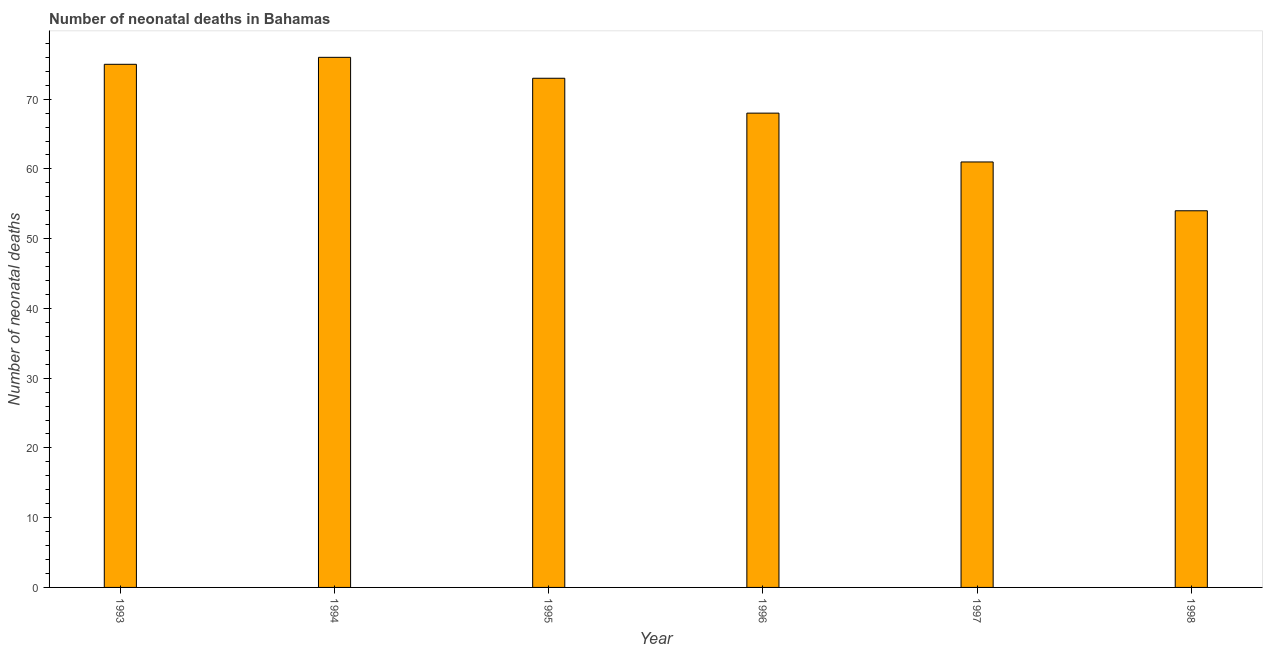Does the graph contain any zero values?
Provide a short and direct response. No. Does the graph contain grids?
Provide a short and direct response. No. What is the title of the graph?
Offer a very short reply. Number of neonatal deaths in Bahamas. What is the label or title of the Y-axis?
Provide a short and direct response. Number of neonatal deaths. What is the number of neonatal deaths in 1997?
Provide a short and direct response. 61. Across all years, what is the minimum number of neonatal deaths?
Make the answer very short. 54. What is the sum of the number of neonatal deaths?
Give a very brief answer. 407. What is the difference between the number of neonatal deaths in 1993 and 1998?
Give a very brief answer. 21. What is the average number of neonatal deaths per year?
Offer a terse response. 67. What is the median number of neonatal deaths?
Ensure brevity in your answer.  70.5. In how many years, is the number of neonatal deaths greater than 40 ?
Make the answer very short. 6. What is the ratio of the number of neonatal deaths in 1993 to that in 1998?
Ensure brevity in your answer.  1.39. Is the number of neonatal deaths in 1993 less than that in 1994?
Make the answer very short. Yes. Is the difference between the number of neonatal deaths in 1993 and 1998 greater than the difference between any two years?
Your answer should be compact. No. What is the difference between the highest and the second highest number of neonatal deaths?
Keep it short and to the point. 1. In how many years, is the number of neonatal deaths greater than the average number of neonatal deaths taken over all years?
Keep it short and to the point. 4. What is the difference between two consecutive major ticks on the Y-axis?
Give a very brief answer. 10. Are the values on the major ticks of Y-axis written in scientific E-notation?
Your response must be concise. No. What is the Number of neonatal deaths of 1993?
Provide a short and direct response. 75. What is the Number of neonatal deaths in 1994?
Offer a very short reply. 76. What is the Number of neonatal deaths of 1996?
Offer a very short reply. 68. What is the Number of neonatal deaths of 1998?
Your answer should be compact. 54. What is the difference between the Number of neonatal deaths in 1993 and 1994?
Your answer should be very brief. -1. What is the difference between the Number of neonatal deaths in 1993 and 1995?
Give a very brief answer. 2. What is the difference between the Number of neonatal deaths in 1993 and 1996?
Provide a short and direct response. 7. What is the difference between the Number of neonatal deaths in 1994 and 1995?
Your response must be concise. 3. What is the difference between the Number of neonatal deaths in 1994 and 1997?
Your answer should be compact. 15. What is the difference between the Number of neonatal deaths in 1994 and 1998?
Your answer should be very brief. 22. What is the difference between the Number of neonatal deaths in 1995 and 1996?
Make the answer very short. 5. What is the difference between the Number of neonatal deaths in 1995 and 1997?
Provide a succinct answer. 12. What is the difference between the Number of neonatal deaths in 1996 and 1997?
Your answer should be very brief. 7. What is the difference between the Number of neonatal deaths in 1997 and 1998?
Offer a very short reply. 7. What is the ratio of the Number of neonatal deaths in 1993 to that in 1994?
Offer a terse response. 0.99. What is the ratio of the Number of neonatal deaths in 1993 to that in 1995?
Your answer should be compact. 1.03. What is the ratio of the Number of neonatal deaths in 1993 to that in 1996?
Offer a very short reply. 1.1. What is the ratio of the Number of neonatal deaths in 1993 to that in 1997?
Provide a short and direct response. 1.23. What is the ratio of the Number of neonatal deaths in 1993 to that in 1998?
Provide a succinct answer. 1.39. What is the ratio of the Number of neonatal deaths in 1994 to that in 1995?
Your answer should be very brief. 1.04. What is the ratio of the Number of neonatal deaths in 1994 to that in 1996?
Provide a short and direct response. 1.12. What is the ratio of the Number of neonatal deaths in 1994 to that in 1997?
Keep it short and to the point. 1.25. What is the ratio of the Number of neonatal deaths in 1994 to that in 1998?
Provide a succinct answer. 1.41. What is the ratio of the Number of neonatal deaths in 1995 to that in 1996?
Provide a succinct answer. 1.07. What is the ratio of the Number of neonatal deaths in 1995 to that in 1997?
Give a very brief answer. 1.2. What is the ratio of the Number of neonatal deaths in 1995 to that in 1998?
Make the answer very short. 1.35. What is the ratio of the Number of neonatal deaths in 1996 to that in 1997?
Offer a very short reply. 1.11. What is the ratio of the Number of neonatal deaths in 1996 to that in 1998?
Your answer should be very brief. 1.26. What is the ratio of the Number of neonatal deaths in 1997 to that in 1998?
Make the answer very short. 1.13. 